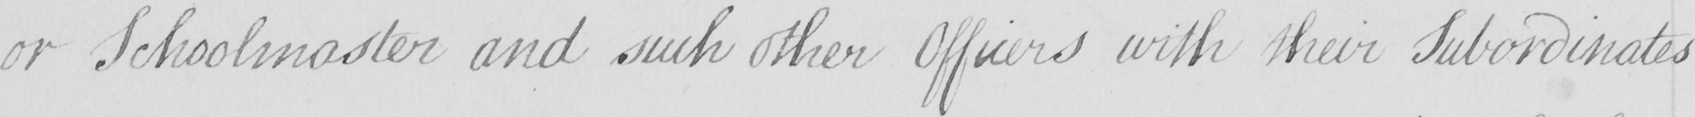What does this handwritten line say? or Schoolmaster and such other Officers with their Subordinates 